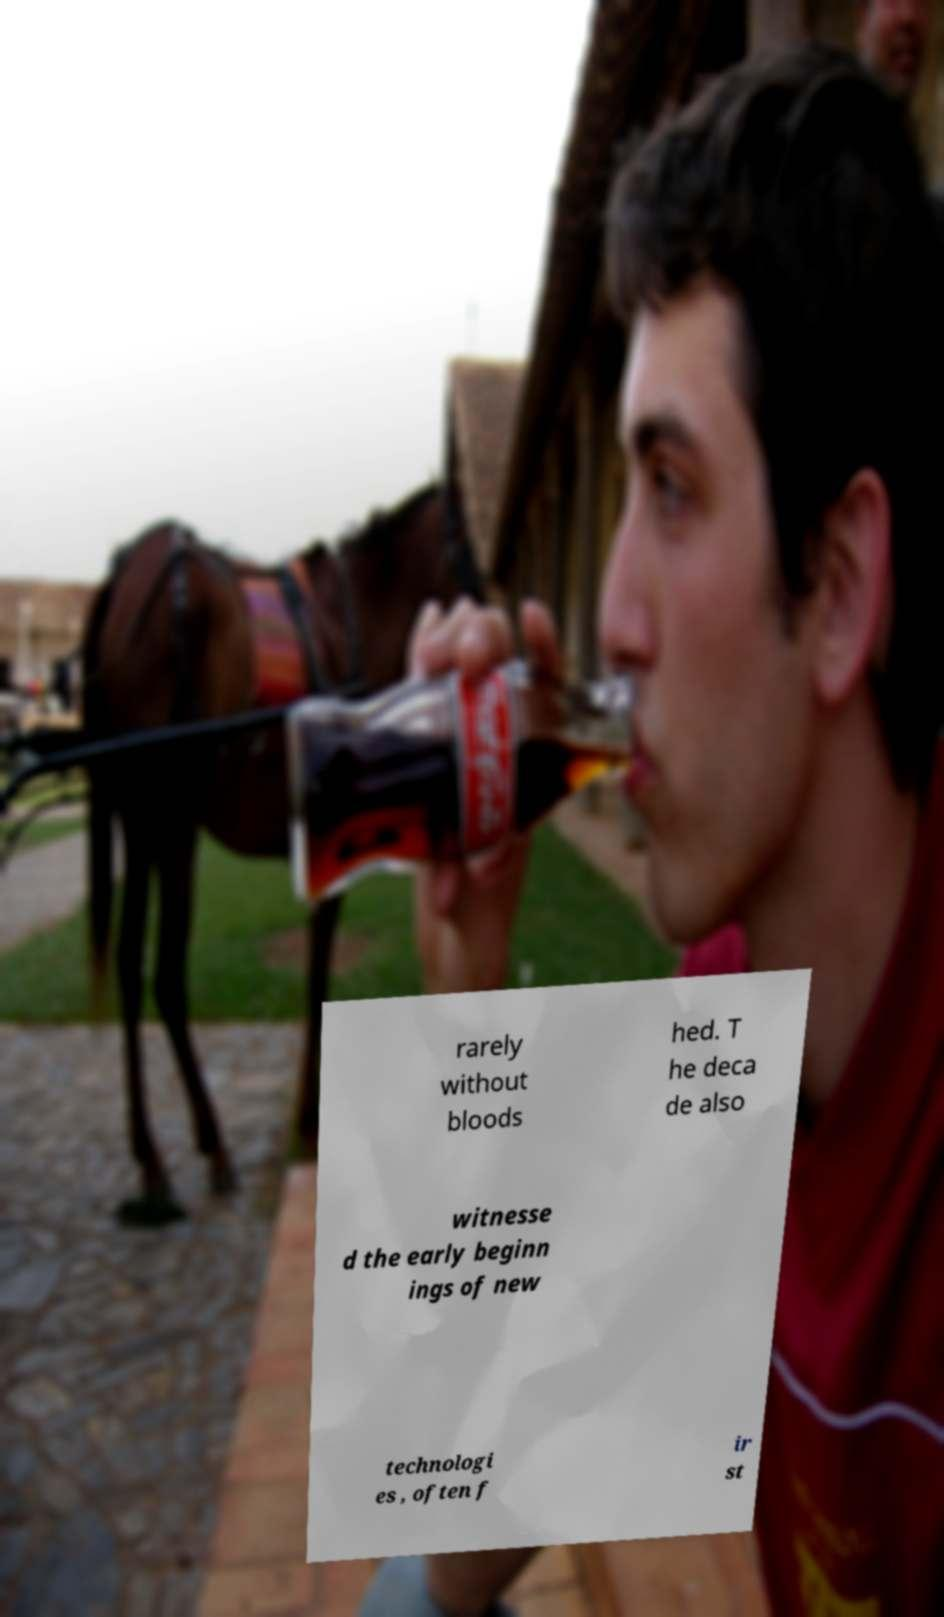Can you read and provide the text displayed in the image?This photo seems to have some interesting text. Can you extract and type it out for me? rarely without bloods hed. T he deca de also witnesse d the early beginn ings of new technologi es , often f ir st 